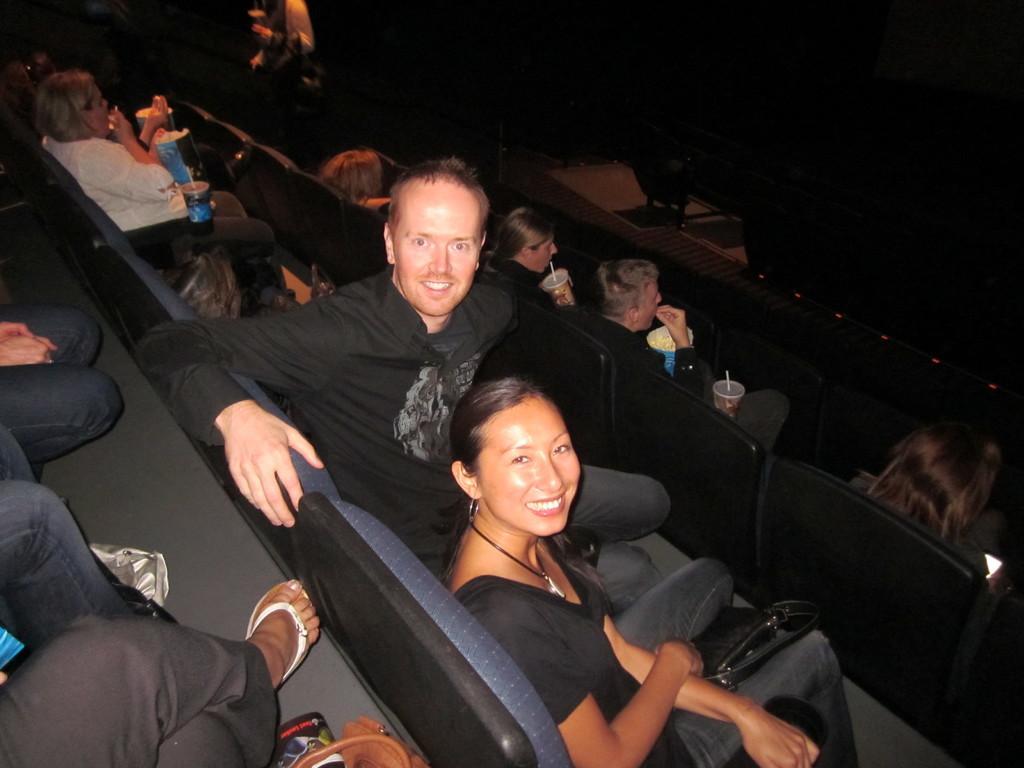How would you summarize this image in a sentence or two? In this picture there is a man who is wearing black dress. He is sitting on the chair. beside him we can see a woman who is also wearing black dress and locket. Both of them are smiling. On the right we can see group of persons who are holding coke can and popcorn. On the top right there is darkness. Here we can see women who is wearing white dress and she is holding bottle. On the bottom left we can see a person wearing a sleeper, near to the her we can see bag. 